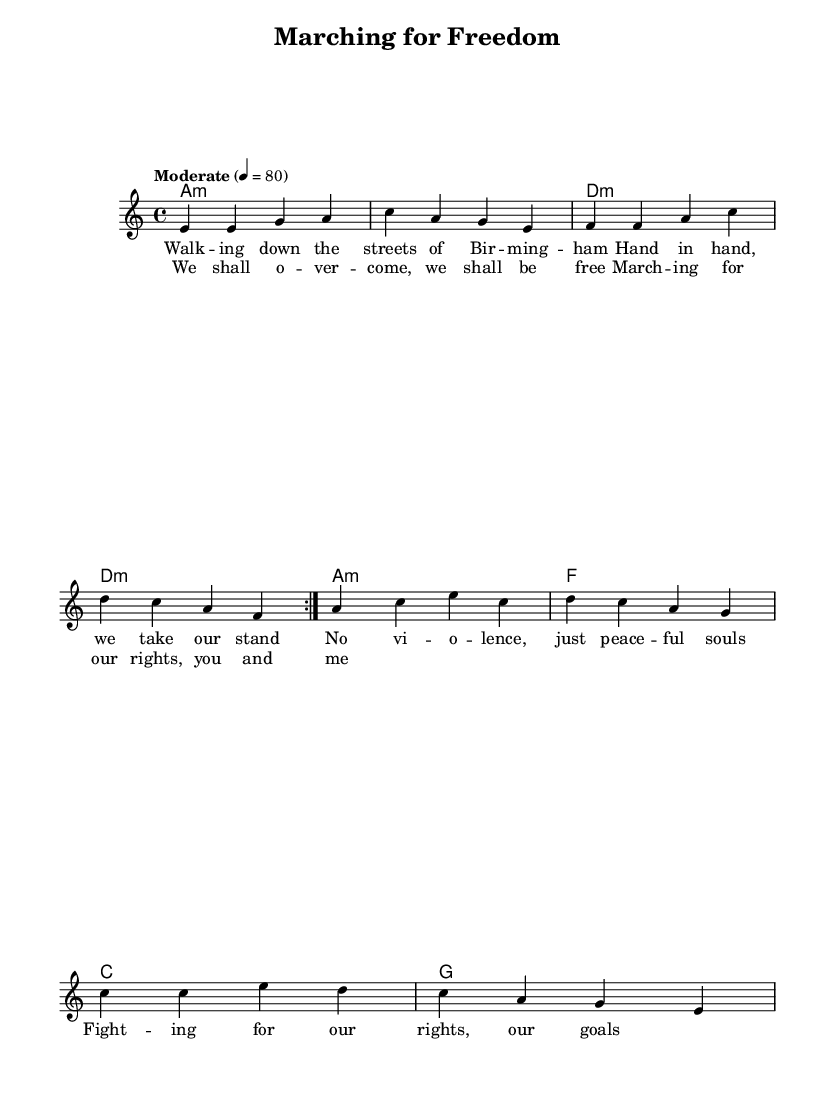What is the key signature of this music? The key signature is A minor, which is indicated at the beginning of the sheet music with one sharp (the G sharp).
Answer: A minor What is the time signature of this music? The time signature is 4/4, as indicated at the beginning of the sheet music, implying there are four beats in each measure.
Answer: 4/4 What is the tempo indication for the music? The tempo indication specifies a "Moderate" tempo of quarter note equals 80 beats per minute, which guides the speed at which the music should be played.
Answer: Moderate 4 equals 80 How many times is the melody repeated in the verse? The melody is repeated 2 times, as indicated by the "repeat volta 2" marking before the melody section.
Answer: 2 times What is the last chord in the song? The last chord shown in the harmonies section is G, which occurs in the final measure of the music.
Answer: G What lyrics are associated with the chorus? The lyrics associated with the chorus are "We shall overcome, we shall be free, Marching for our rights, you and me," which captures the spirit of unity and hope in the song.
Answer: We shall overcome, we shall be free, Marching for our rights, you and me What type of musical form is primarily used in the song? The song primarily follows a verse-chorus structure, typical in blues music, where verses express stories or themes and choruses emphasize the main message.
Answer: Verse-Chorus 